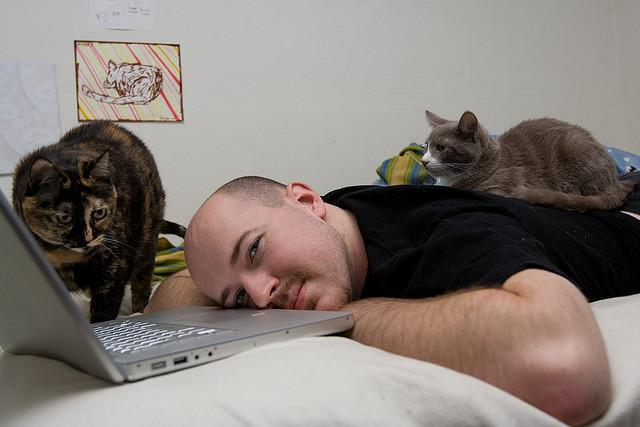How many mammals area shown? Please explain your reasoning. three. Two cats and a human equal 3. 